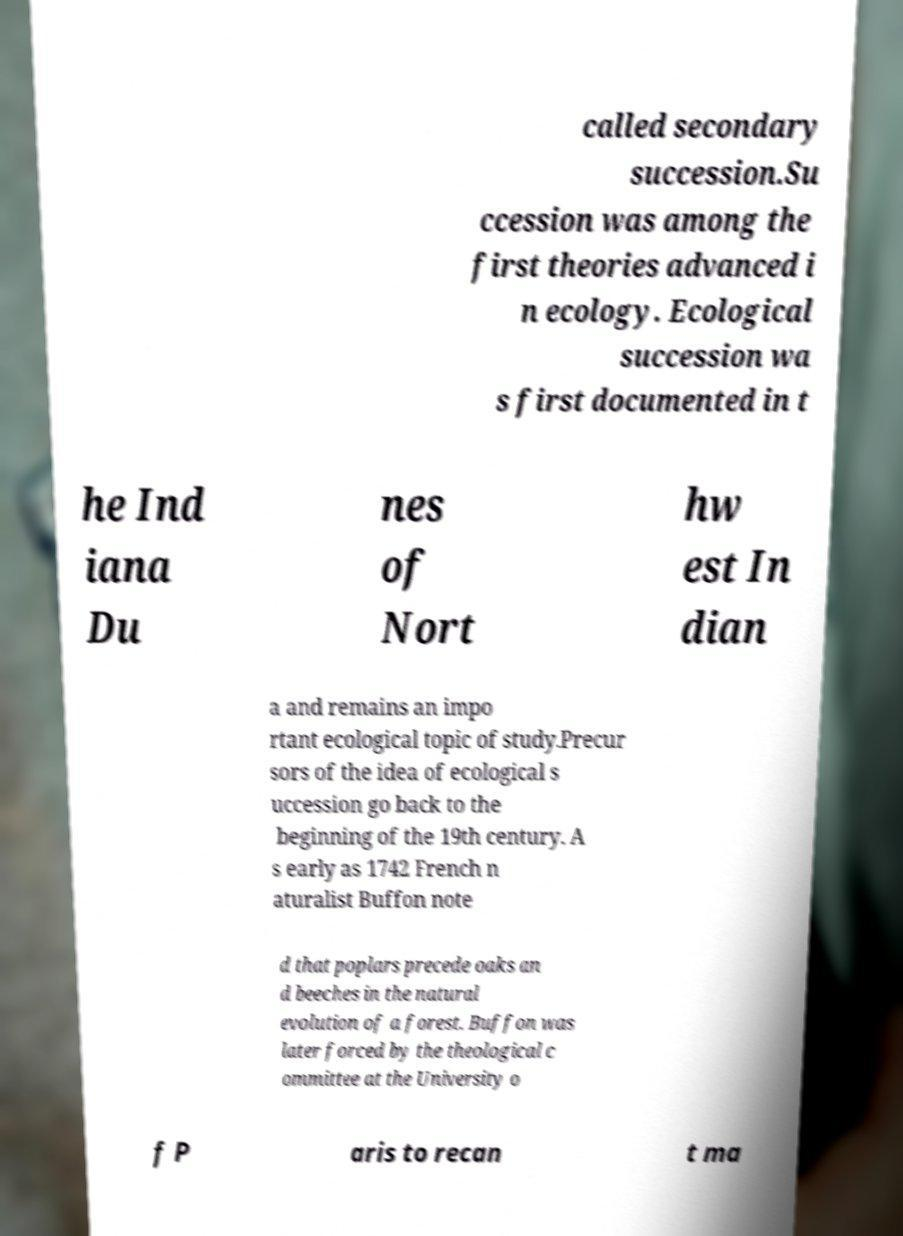There's text embedded in this image that I need extracted. Can you transcribe it verbatim? called secondary succession.Su ccession was among the first theories advanced i n ecology. Ecological succession wa s first documented in t he Ind iana Du nes of Nort hw est In dian a and remains an impo rtant ecological topic of study.Precur sors of the idea of ecological s uccession go back to the beginning of the 19th century. A s early as 1742 French n aturalist Buffon note d that poplars precede oaks an d beeches in the natural evolution of a forest. Buffon was later forced by the theological c ommittee at the University o f P aris to recan t ma 